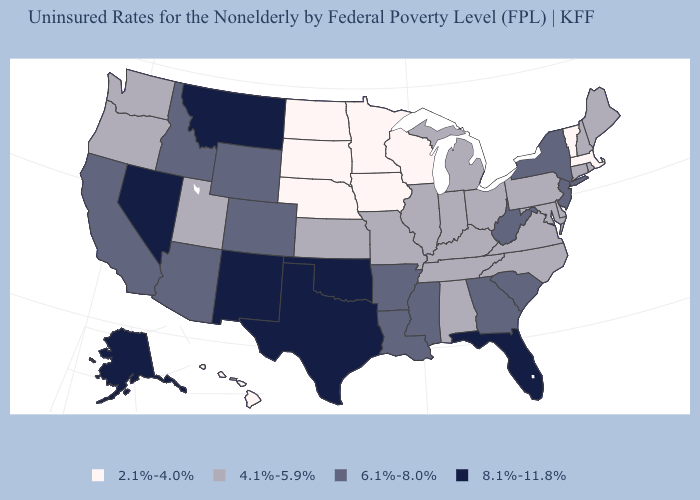Which states have the lowest value in the USA?
Keep it brief. Hawaii, Iowa, Massachusetts, Minnesota, Nebraska, North Dakota, South Dakota, Vermont, Wisconsin. Name the states that have a value in the range 6.1%-8.0%?
Short answer required. Arizona, Arkansas, California, Colorado, Georgia, Idaho, Louisiana, Mississippi, New Jersey, New York, South Carolina, West Virginia, Wyoming. What is the value of Hawaii?
Concise answer only. 2.1%-4.0%. Name the states that have a value in the range 4.1%-5.9%?
Write a very short answer. Alabama, Connecticut, Delaware, Illinois, Indiana, Kansas, Kentucky, Maine, Maryland, Michigan, Missouri, New Hampshire, North Carolina, Ohio, Oregon, Pennsylvania, Rhode Island, Tennessee, Utah, Virginia, Washington. What is the value of Utah?
Write a very short answer. 4.1%-5.9%. What is the lowest value in the MidWest?
Answer briefly. 2.1%-4.0%. What is the value of Georgia?
Keep it brief. 6.1%-8.0%. Name the states that have a value in the range 2.1%-4.0%?
Keep it brief. Hawaii, Iowa, Massachusetts, Minnesota, Nebraska, North Dakota, South Dakota, Vermont, Wisconsin. What is the value of Kansas?
Write a very short answer. 4.1%-5.9%. Does Connecticut have a lower value than New Jersey?
Write a very short answer. Yes. What is the highest value in the West ?
Be succinct. 8.1%-11.8%. Which states have the lowest value in the USA?
Quick response, please. Hawaii, Iowa, Massachusetts, Minnesota, Nebraska, North Dakota, South Dakota, Vermont, Wisconsin. What is the value of Alaska?
Be succinct. 8.1%-11.8%. Does Michigan have the lowest value in the MidWest?
Answer briefly. No. What is the highest value in the USA?
Give a very brief answer. 8.1%-11.8%. 